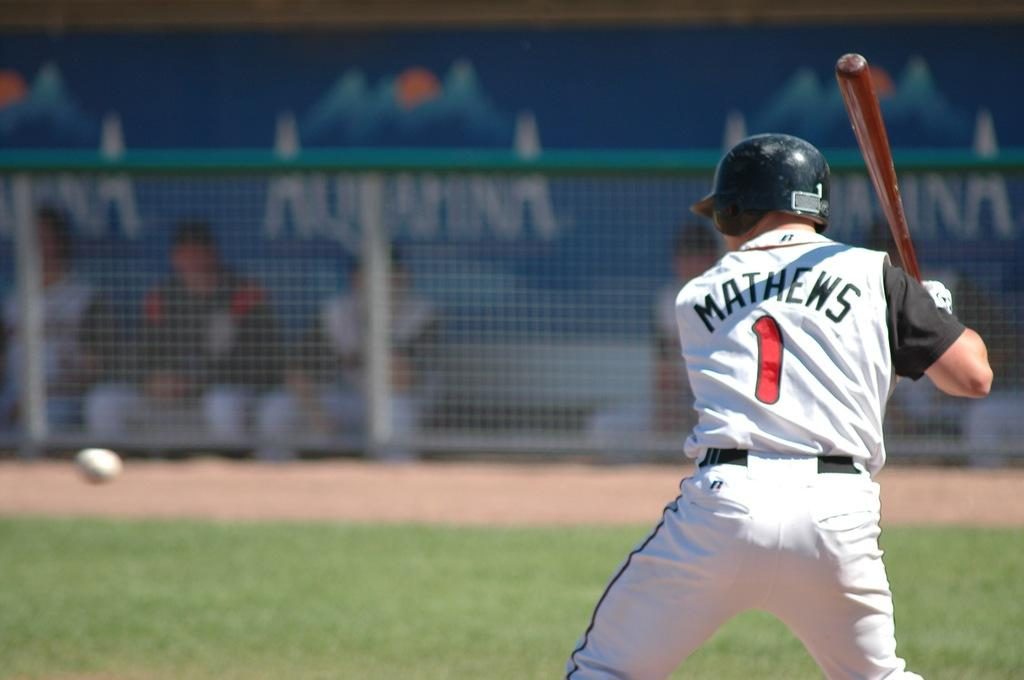<image>
Write a terse but informative summary of the picture. Baseball player with the number 1 on his back about to bat. 